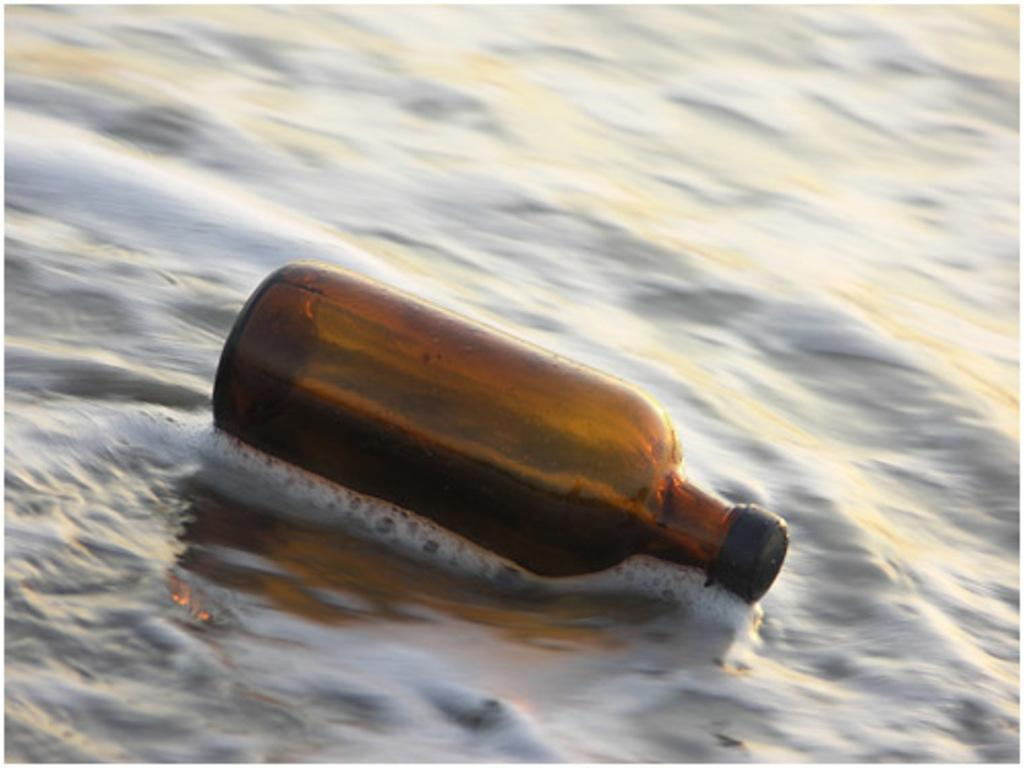What object can be seen in the image? There is a bottle in the image. How is the bottle positioned in the image? The bottle is floating on the water. Where is the jail located in the image? There is no jail present in the image; it only features a bottle floating on the water. What type of trousers are being worn by the bottle in the image? The bottle is an inanimate object and does not wear trousers. 